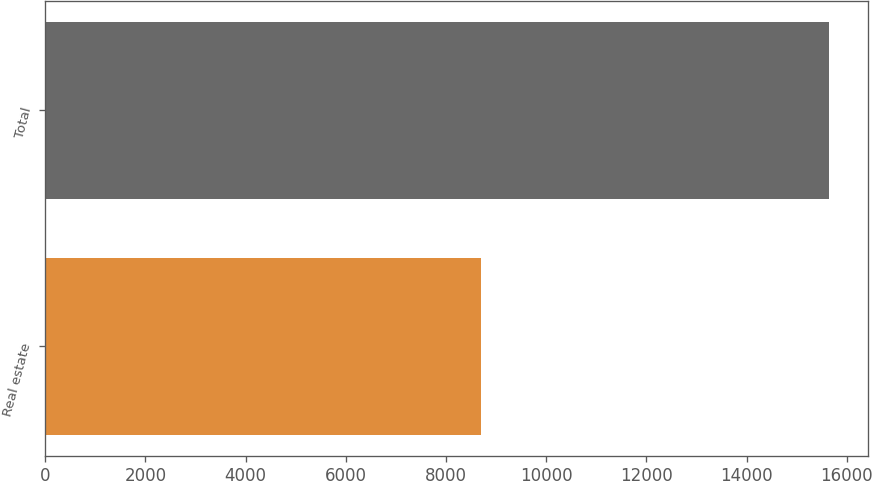Convert chart to OTSL. <chart><loc_0><loc_0><loc_500><loc_500><bar_chart><fcel>Real estate<fcel>Total<nl><fcel>8690<fcel>15645<nl></chart> 